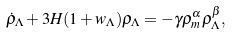Convert formula to latex. <formula><loc_0><loc_0><loc_500><loc_500>\dot { \rho } _ { \Lambda } + 3 H ( 1 + w _ { \Lambda } ) \rho _ { \Lambda } = - \gamma \rho _ { m } ^ { \alpha } \rho _ { \Lambda } ^ { \beta } ,</formula> 